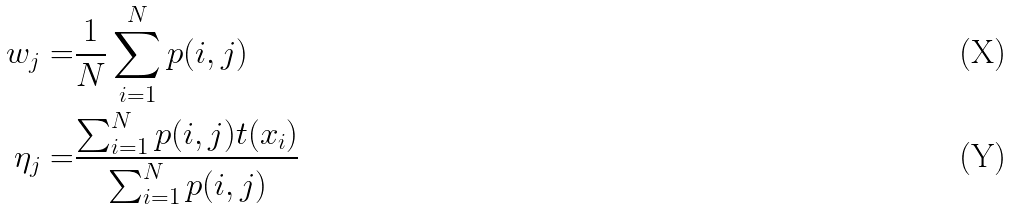Convert formula to latex. <formula><loc_0><loc_0><loc_500><loc_500>w _ { j } = & \frac { 1 } { N } \sum _ { i = 1 } ^ { N } p ( i , j ) \\ \eta _ { j } = & \frac { \sum _ { i = 1 } ^ { N } p ( i , j ) t ( x _ { i } ) } { \sum _ { i = 1 } ^ { N } p ( i , j ) }</formula> 